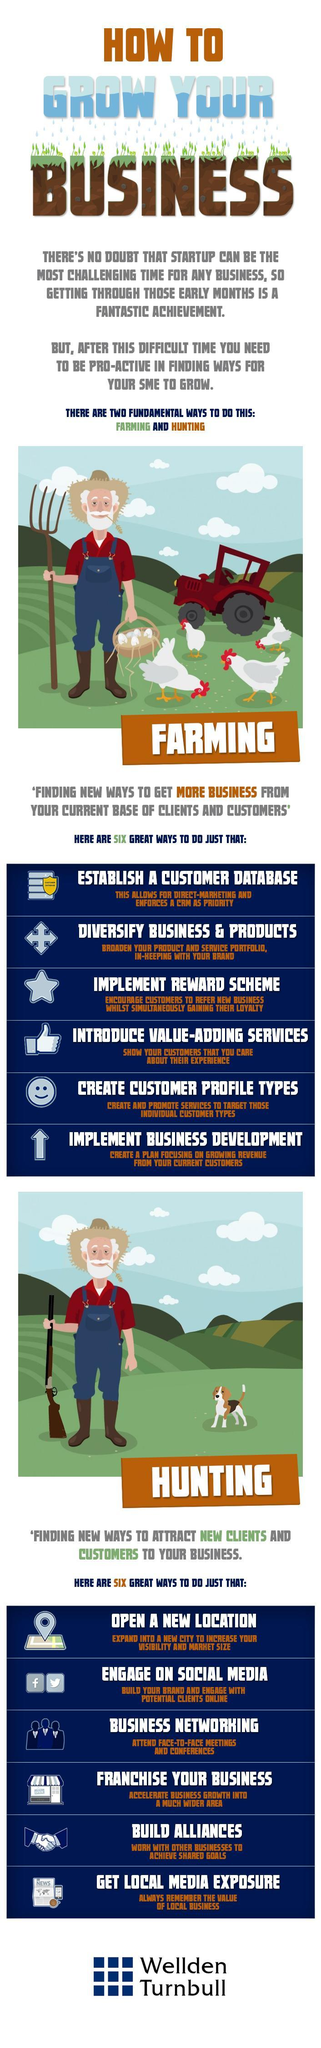What is the fourth point listed under "Hunting"?
Answer the question with a short phrase. Franchise your Business What is the fifth point listed under "Farming"? Create Customer Profile Types What is the second point listed under "Hunting"? Engage on Social Media What is the third point listed under "Farming"? Implement Reward Scheme Which are the best methods to be followed for an excellent growth in SMEs? Farming and Hunting 